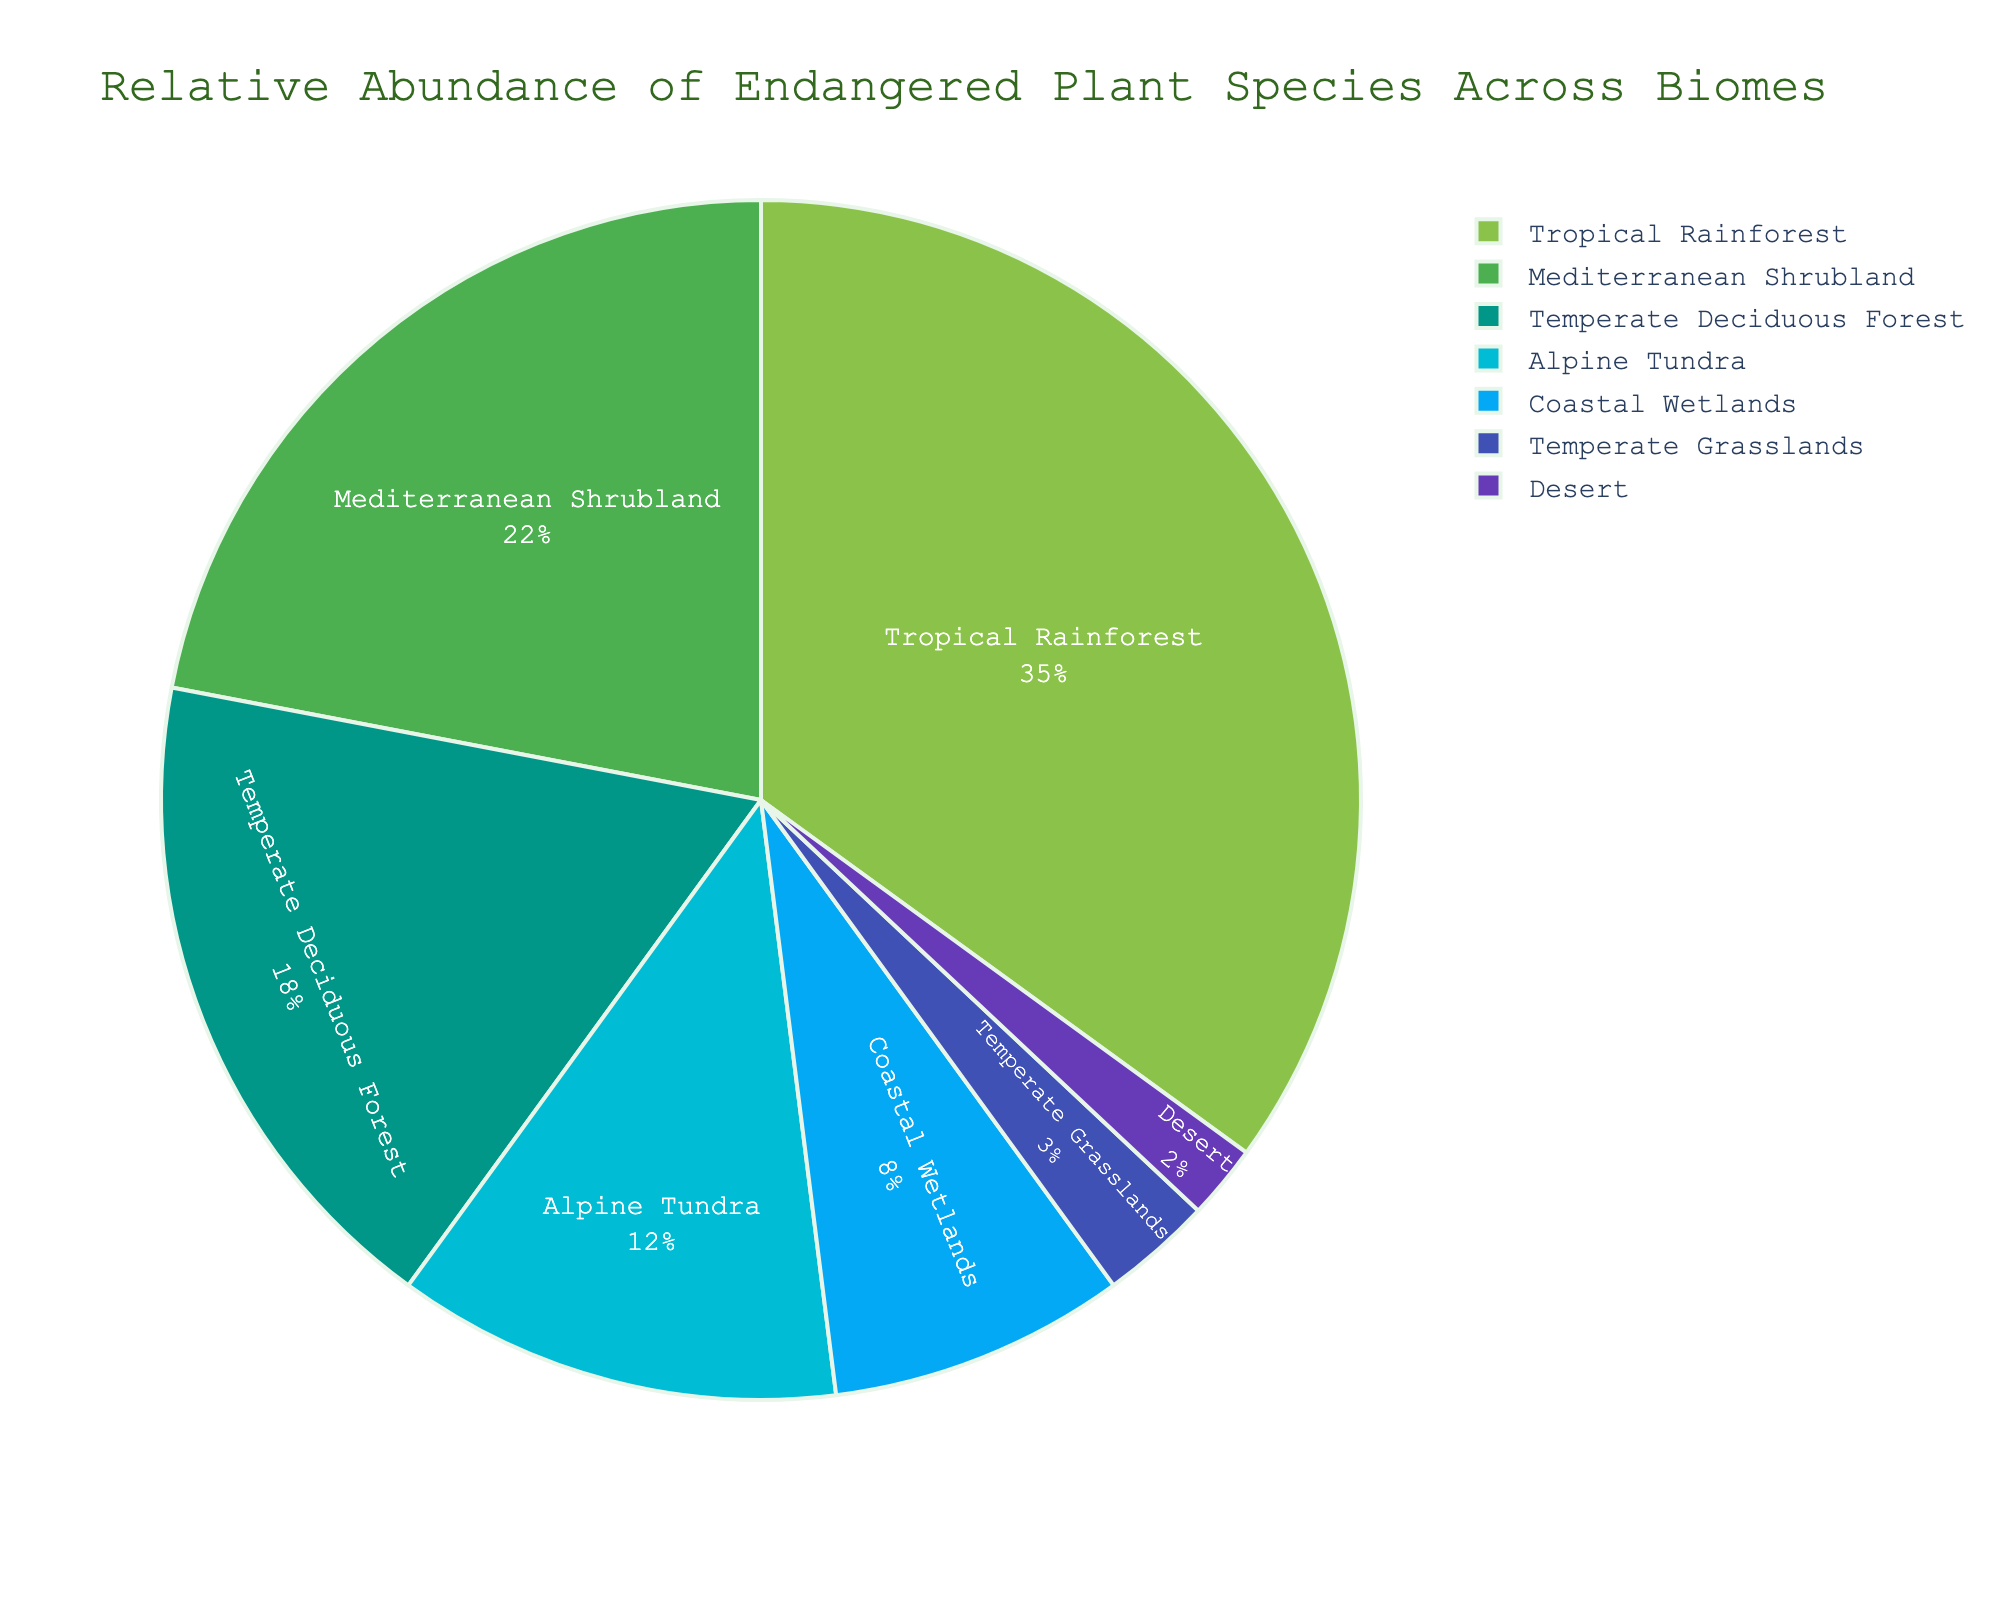What's the two lowest percentages in the chart combined? The two lowest percentages are for Desert (2%) and Temperate Grasslands (3%). Adding these together, 2% + 3% = 5%.
Answer: 5% Compared to Coastal Wetlands, which biome has a higher percentage, and by how much? Coastal Wetlands have 8%. The Temperate Deciduous Forest has a higher percentage at 18%. The difference is 18% - 8% = 10%.
Answer: Temperate Deciduous Forest, 10% What percentage do all biomes except Tropical Rainforest make up? The percentage of the Tropical Rainforest is 35%. The total percentage is 100%. Therefore, the combined percentage of all other biomes is 100% - 35% = 65%.
Answer: 65% Which biomes have a percentage over 20%? Tropical Rainforest (35%) and Mediterranean Shrubland (22%) are the biomes with percentages over 20%.
Answer: Tropical Rainforest, Mediterranean Shrubland How much more abundant are endangered plant species in Alpine Tundra compared to Desert? Alpine Tundra has 12% while Desert has 2%. The difference is 12% - 2% = 10%.
Answer: 10% Which section in the pie chart is represented by the color green? The pie chart uses a custom color palette inspired by botanical colors, where the Tropical Rainforest is represented by the color green.
Answer: Tropical Rainforest What is the combined percentage of Mediterranean Shrubland and Coastal Wetlands? Mediterranean Shrubland has 22% and Coastal Wetlands have 8%. Adding these together, 22% + 8% = 30%.
Answer: 30% Which biome has a higher percentage: Temperate Grasslands or Alpine Tundra, and by what factor? Alpine Tundra has 12% while Temperate Grasslands have 3%. The factor difference is 12% / 3% = 4.
Answer: Alpine Tundra, 4 times If the percentage of Temperate Deciduous Forest increased by 5%, what would its new percentage be? Currently, Temperate Deciduous Forest is at 18%. An increase of 5% makes it 18% + 5% = 23%.
Answer: 23% What percent of the chart do Temperate Deciduous Forest, Coastal Wetlands, and Desert makeup when combined? Temperate Deciduous Forest is 18%, Coastal Wetlands are 8%, and Desert is 2%. Their combined total is 18% + 8% + 2% = 28%.
Answer: 28% 